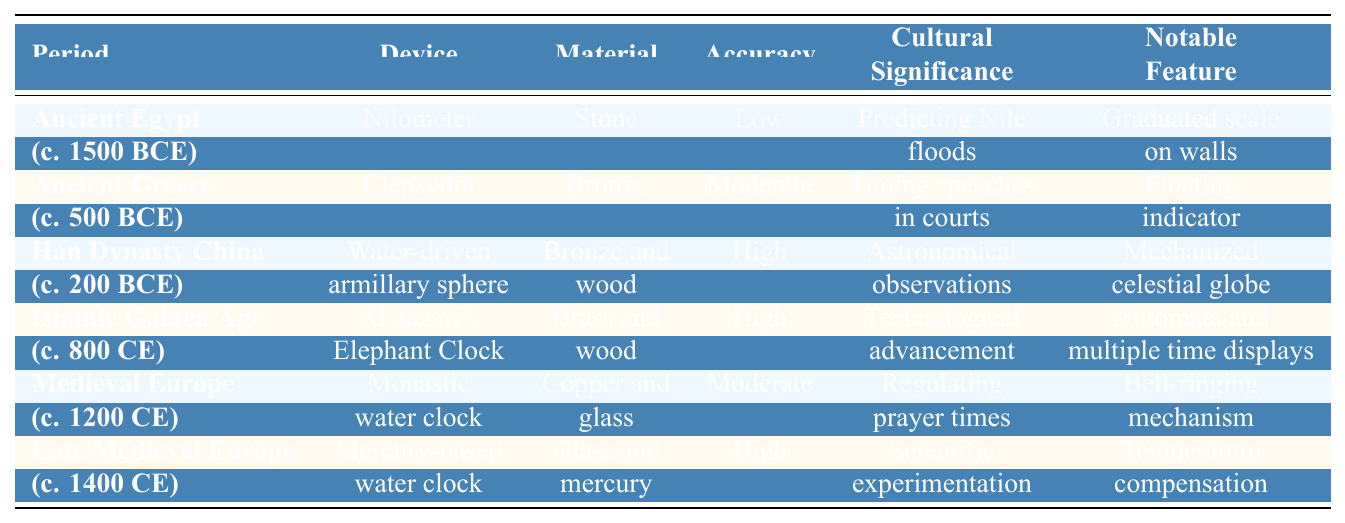What was the primary cultural significance of the Nilometer in Ancient Egypt? The Nilometer was significant for predicting Nile floods, which was crucial for agriculture and resource management in Ancient Egypt. This is stated in the "Cultural Significance" column for the Nilometer entry.
Answer: Predicting Nile floods Which water clock had the highest accuracy in its design? The Han Dynasty China's water-driven armillary sphere and both the Islamic Golden Age's Al-Jazari's Elephant Clock, as well as the Late Medieval Europe's mercury-based water clock, all had high accuracy. We see "High" listed in the "Accuracy" column for these three entries.
Answer: Han Dynasty China's water-driven armillary sphere, Al-Jazari's Elephant Clock, and Late Medieval Europe's mercury-based water clock Did the Clepsydra from Ancient Greece have a higher accuracy compared to the Monastic water clock from Medieval Europe? The Clepsydra had moderate accuracy while the Monastic water clock also had moderate accuracy. Therefore, they are equal as both have the same accuracy level according to their respective entries in the "Accuracy" column.
Answer: No What materials were used in the construction of the Mercury-based water clock and what was its primary cultural significance? The Mercury-based water clock was made of glass and mercury, and its primary cultural significance was scientific experimentation as noted in the "Material" and "Cultural Significance" columns.
Answer: Glass and mercury; Scientific experimentation Which period featured a water clock that included temperature compensation as a notable feature? The Late Medieval Europe period featured the mercury-based water clock, which included temperature compensation as a notable feature. This is found in the "Notable Feature" column for that entry.
Answer: Late Medieval Europe How many devices listed in the table are made from bronze? There are three devices made from bronze: the Clepsydra, the water-driven armillary sphere, and Al-Jazari's Elephant Clock. We count these entries in the "Material" column that specifically mention bronze.
Answer: Three Is it true that all devices listed in the table feature a unique notable feature? Yes, every device has a distinct notable feature mentioned in the "Notable Feature" column, indicating that each one has a specific characteristic that sets it apart from others.
Answer: Yes Which water clock was primarily used for timing speeches in courts and during what period? The Clepsydra, used in Ancient Greece around 500 BCE, was primarily for timing speeches in courts as indicated in the respective columns for this device.
Answer: Clepsydra; Ancient Greece (c. 500 BCE) What notable feature distinguishes Al-Jazari's Elephant Clock from the other devices? The notable feature of Al-Jazari's Elephant Clock is that it included automata and multiple time displays, which distinguishes it compared to other listed devices. This is mentioned explicitly in the relevant column.
Answer: Automata and multiple time displays Which water clock had its accuracy rated as low, and what was its material? The Nilometer from Ancient Egypt had its accuracy rated as low and was made of stone, as mentioned in the "Accuracy" and "Material" columns.
Answer: Nilometer; Stone How would you compare the cultural significance of water clocks from the Islamic Golden Age and Medieval Europe? The Al-Jazari's Elephant Clock from the Islamic Golden Age was noted for technological advancement, while the Monastic water clock from Medieval Europe served to regulate prayer times. The cultural significance reflects different priorities and achievements during these periods, implying advancement in technology in the earlier era versus a focus on religious practices in the later period.
Answer: Different; technological advancement vs. regulating prayer times 